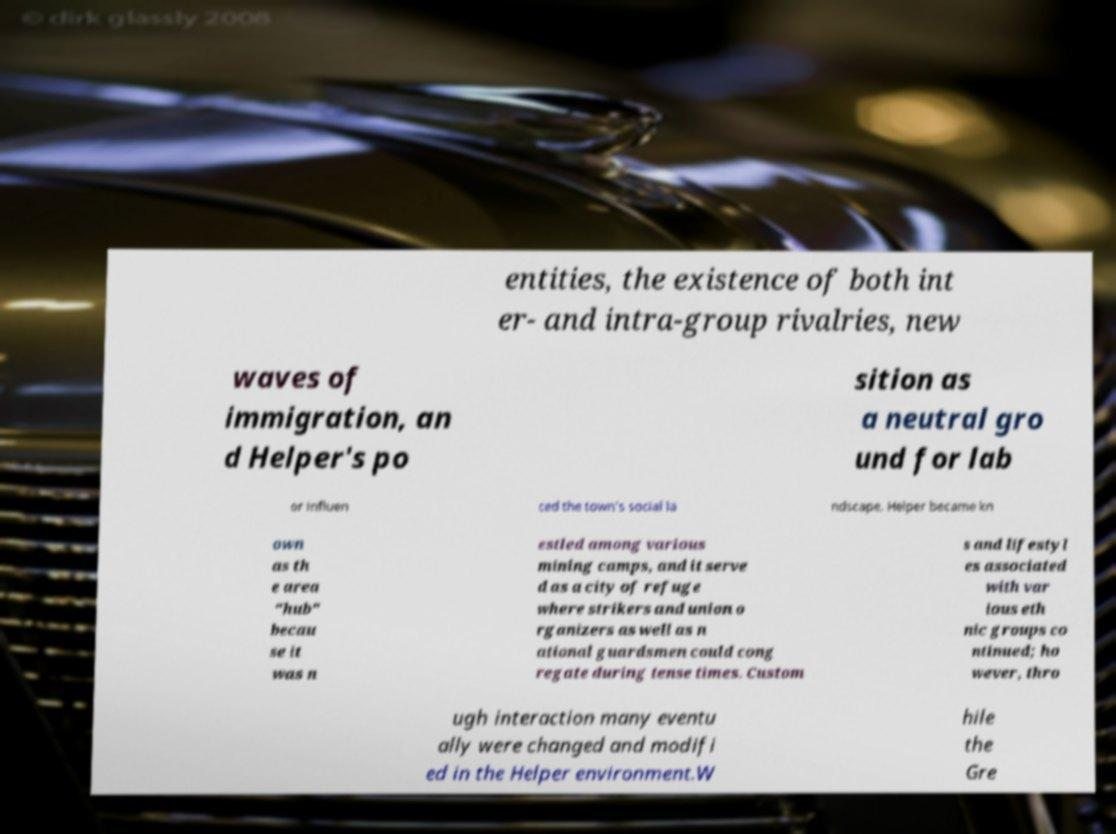I need the written content from this picture converted into text. Can you do that? entities, the existence of both int er- and intra-group rivalries, new waves of immigration, an d Helper's po sition as a neutral gro und for lab or influen ced the town's social la ndscape. Helper became kn own as th e area "hub" becau se it was n estled among various mining camps, and it serve d as a city of refuge where strikers and union o rganizers as well as n ational guardsmen could cong regate during tense times. Custom s and lifestyl es associated with var ious eth nic groups co ntinued; ho wever, thro ugh interaction many eventu ally were changed and modifi ed in the Helper environment.W hile the Gre 